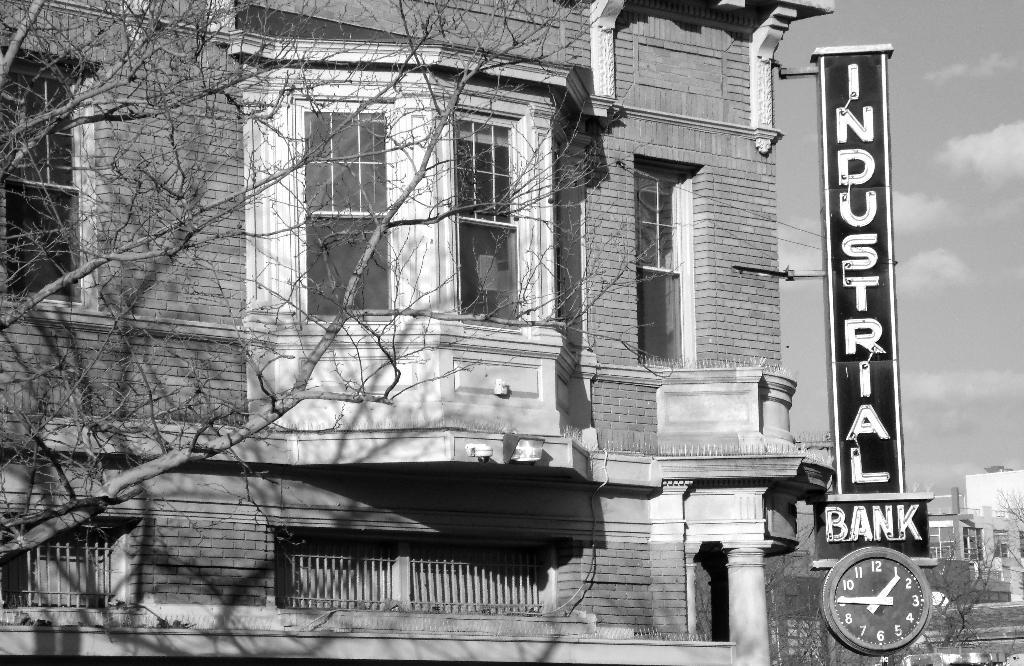<image>
Present a compact description of the photo's key features. An Industrial Bank sign and clock are on the corner of a building. 